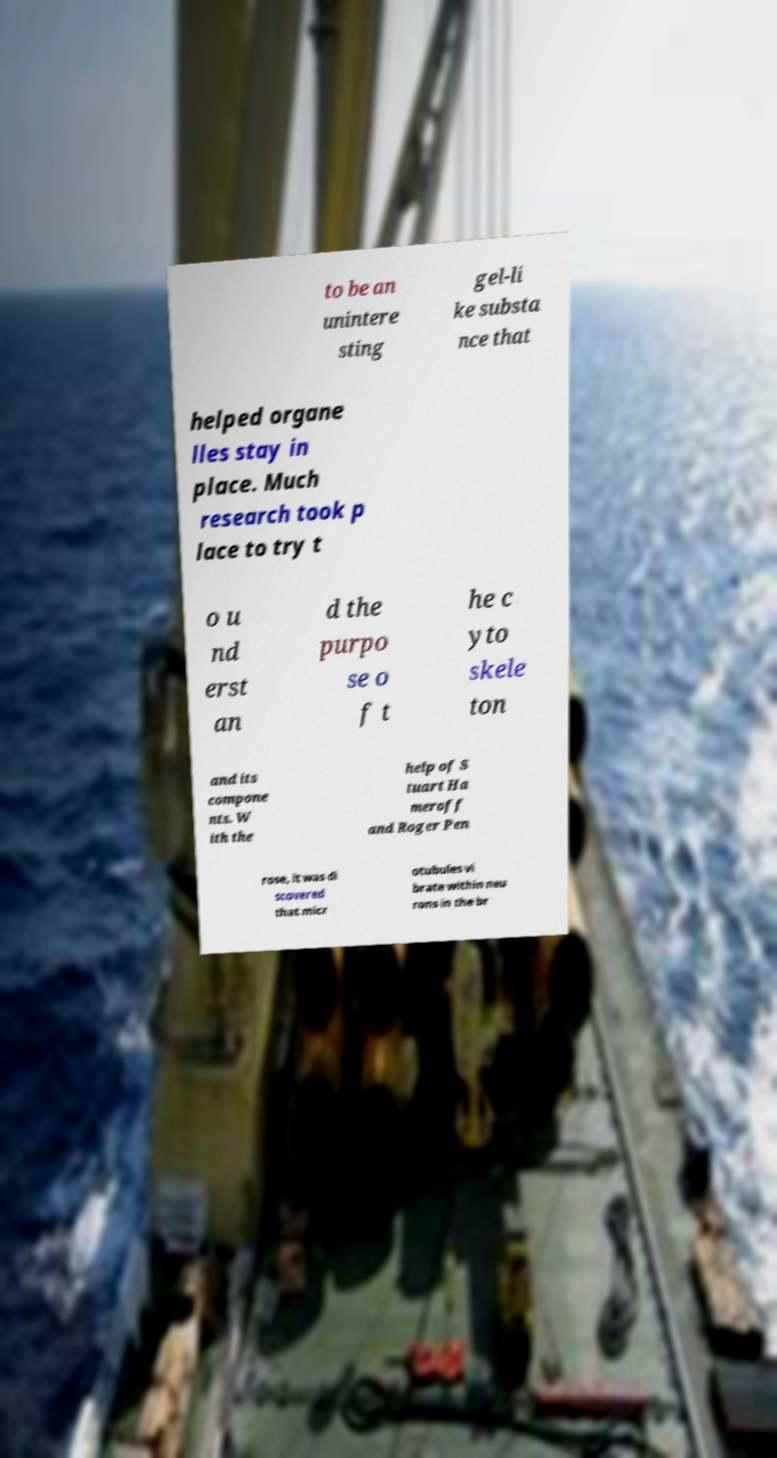Could you extract and type out the text from this image? to be an unintere sting gel-li ke substa nce that helped organe lles stay in place. Much research took p lace to try t o u nd erst an d the purpo se o f t he c yto skele ton and its compone nts. W ith the help of S tuart Ha meroff and Roger Pen rose, it was di scovered that micr otubules vi brate within neu rons in the br 